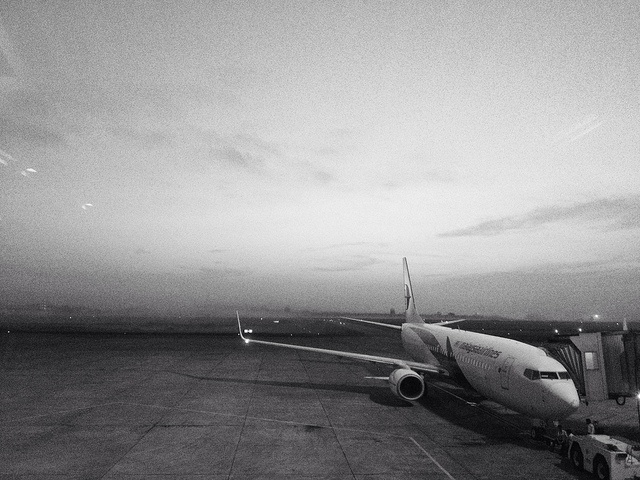Describe the objects in this image and their specific colors. I can see airplane in gray, black, darkgray, and lightgray tones, people in black and gray tones, people in gray and black tones, and people in gray and black tones in this image. 